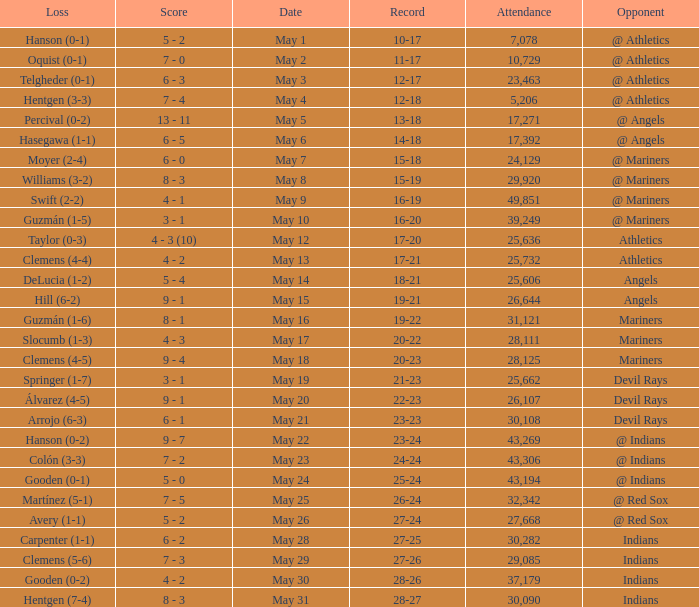Who lost on May 31? Hentgen (7-4). 